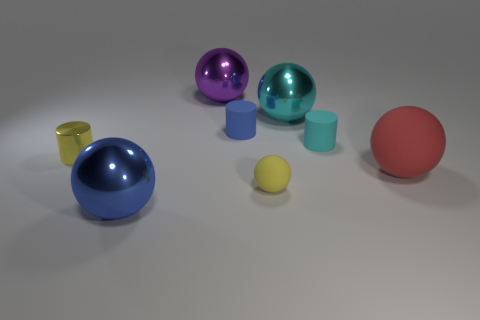Subtract all blue balls. How many balls are left? 4 Subtract all cyan shiny balls. How many balls are left? 4 Add 1 big metallic objects. How many objects exist? 9 Subtract all red balls. Subtract all brown cubes. How many balls are left? 4 Subtract all cylinders. How many objects are left? 5 Subtract all yellow rubber objects. Subtract all small rubber things. How many objects are left? 4 Add 3 large cyan shiny objects. How many large cyan shiny objects are left? 4 Add 3 matte spheres. How many matte spheres exist? 5 Subtract 1 purple spheres. How many objects are left? 7 